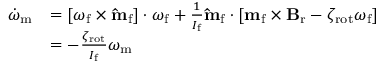Convert formula to latex. <formula><loc_0><loc_0><loc_500><loc_500>\begin{array} { r l } { \dot { \omega } _ { m } } & { = [ \omega _ { f } \times \hat { m } _ { f } ] \cdot \omega _ { f } + \frac { 1 } { I _ { f } } \hat { m } _ { f } \cdot [ m _ { f } \times B _ { r } - \zeta _ { r o t } \omega _ { f } ] } \\ & { = - \frac { \zeta _ { r o t } } { I _ { f } } \omega _ { m } } \end{array}</formula> 